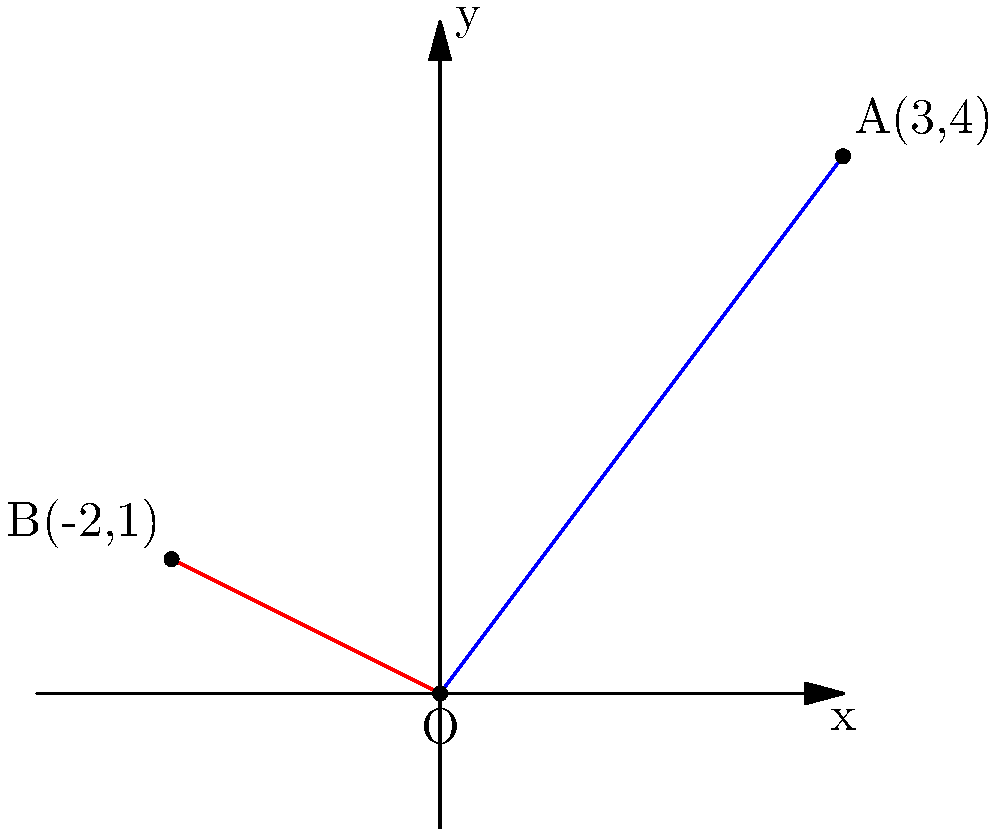Hey, remember those geometry classes we used to skip to hang out behind the bleachers? Well, I've got a problem here that reminds me of those days. There are two lines on this coordinate plane: one goes from the origin to point A(3,4), and the other from the origin to point B(-2,1). What's the angle between these lines? Maybe if we'd paid more attention in class, this would be a breeze! Alright, let's tackle this step-by-step:

1) To find the angle between two lines, we can use the dot product formula:

   $$\cos \theta = \frac{\vec{a} \cdot \vec{b}}{|\vec{a}||\vec{b}|}$$

2) Vector $\vec{a}$ is OA, which is (3,4), and vector $\vec{b}$ is OB, which is (-2,1).

3) Let's calculate the dot product $\vec{a} \cdot \vec{b}$:
   $$\vec{a} \cdot \vec{b} = (3)(-2) + (4)(1) = -6 + 4 = -2$$

4) Now, let's calculate the magnitudes:
   $$|\vec{a}| = \sqrt{3^2 + 4^2} = \sqrt{9 + 16} = \sqrt{25} = 5$$
   $$|\vec{b}| = \sqrt{(-2)^2 + 1^2} = \sqrt{4 + 1} = \sqrt{5}$$

5) Plugging these into our formula:
   $$\cos \theta = \frac{-2}{5\sqrt{5}}$$

6) To get $\theta$, we need to take the inverse cosine (arccos) of both sides:
   $$\theta = \arccos(\frac{-2}{5\sqrt{5}})$$

7) Using a calculator, we get:
   $$\theta \approx 2.0344 \text{ radians}$$

8) Converting to degrees:
   $$\theta \approx 116.57°$$
Answer: $116.57°$ 